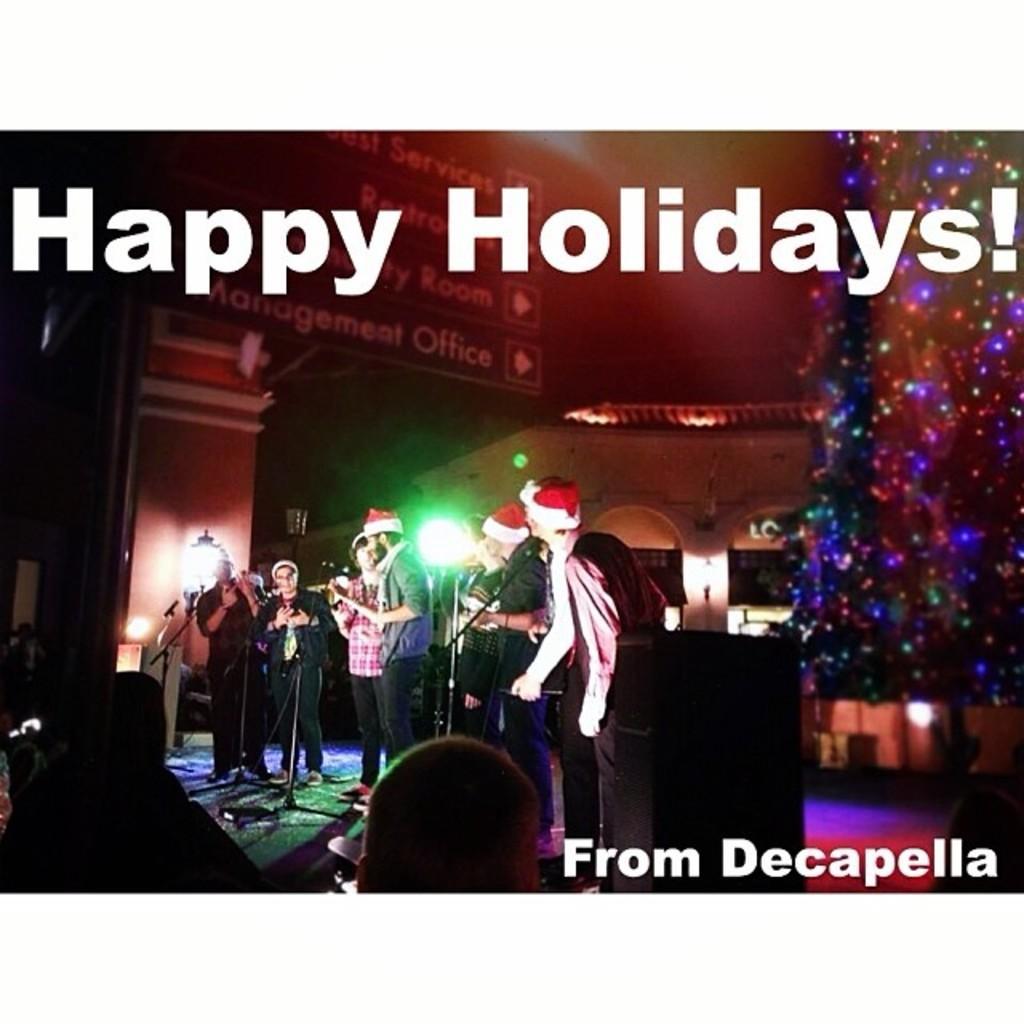Can you describe this image briefly? In this image we can see few people standing on the stage and there are mics in front of them, there are few lights, a building and an object looks like a Christmas tree with lights on the right side. 